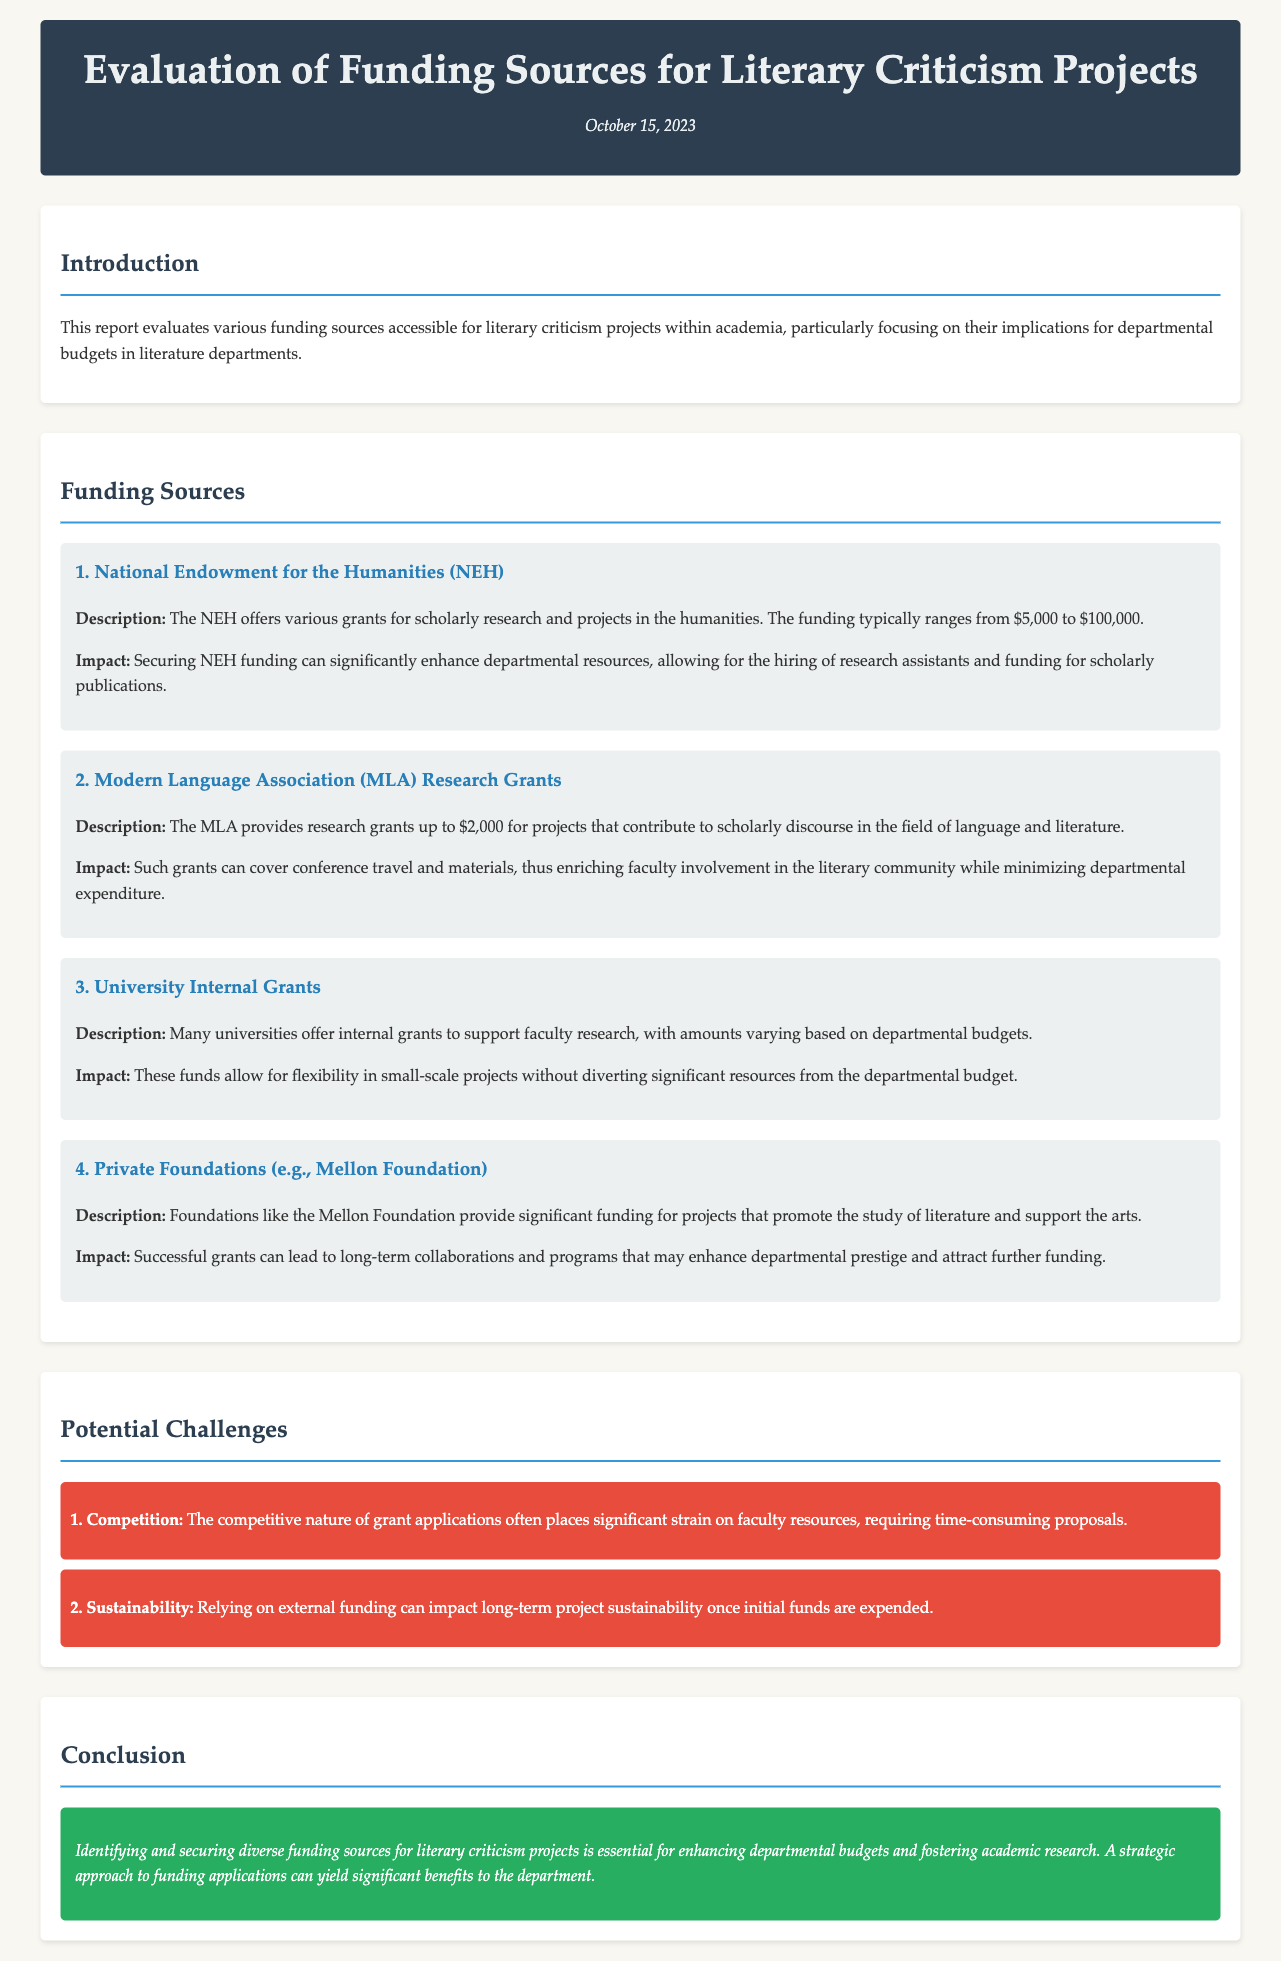What is the title of the report? The title is prominently displayed at the top of the document under the header section.
Answer: Evaluation of Funding Sources for Literary Criticism Projects What is the date of publication? The date is provided in the header section of the document.
Answer: October 15, 2023 What is the funding range offered by the NEH? This information is included in the description of the NEH funding source within the funding sources section.
Answer: $5,000 to $100,000 What type of grants does the MLA provide? The MLA funding source specifies the type of funding it offers within its description.
Answer: Research grants What is one challenge mentioned related to competition? This challenge is listed in the potential challenges section and highlights the competitive nature of grant applications.
Answer: Time-consuming proposals What is the impact of securing NEH funding? The impact is described in the funding sources section under the NEH funding source.
Answer: Enhance departmental resources What does the report conclude regarding funding sources? The conclusion summarizes the necessity of identifying funding sources within the conclusion section.
Answer: Essential for enhancing departmental budgets What is a key feature of university internal grants? This information can be inferred from the description provided in the university internal grants section of the funding sources.
Answer: Flexibility in small-scale projects What does reliance on external funding impact? This concern is addressed in the potential challenges section under sustainability.
Answer: Long-term project sustainability 